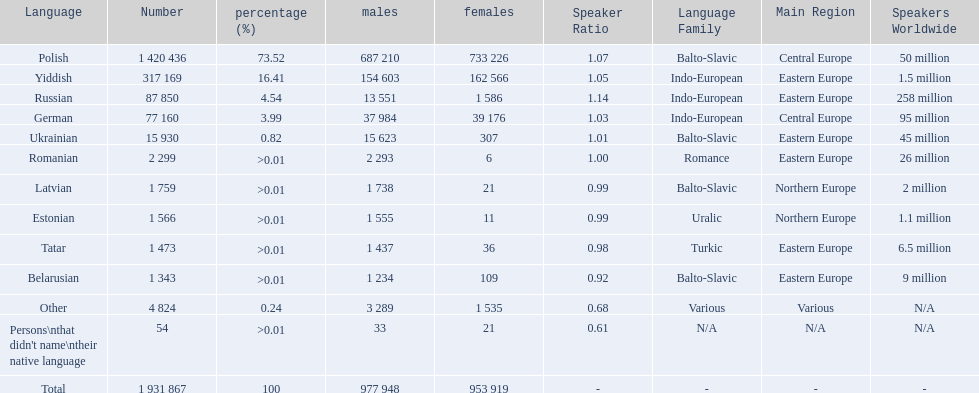What languages are spoken in the warsaw governorate? Polish, Yiddish, Russian, German, Ukrainian, Romanian, Latvian, Estonian, Tatar, Belarusian, Other, Persons\nthat didn't name\ntheir native language. What is the number for russian? 87 850. On this list what is the next lowest number? 77 160. Which language has a number of 77160 speakers? German. 